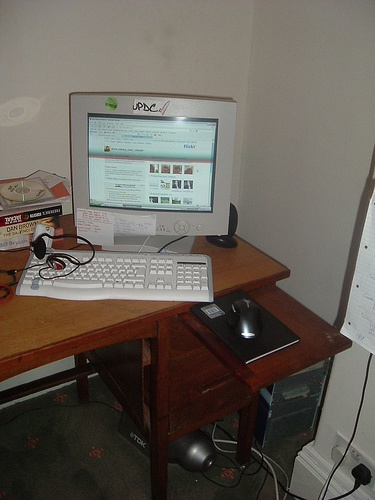Describe the objects in this image and their specific colors. I can see tv in gray, darkgray, and lightblue tones, keyboard in gray, darkgray, lightgray, and black tones, mouse in gray, black, white, and darkgray tones, book in gray, black, maroon, and darkgray tones, and book in gray and black tones in this image. 